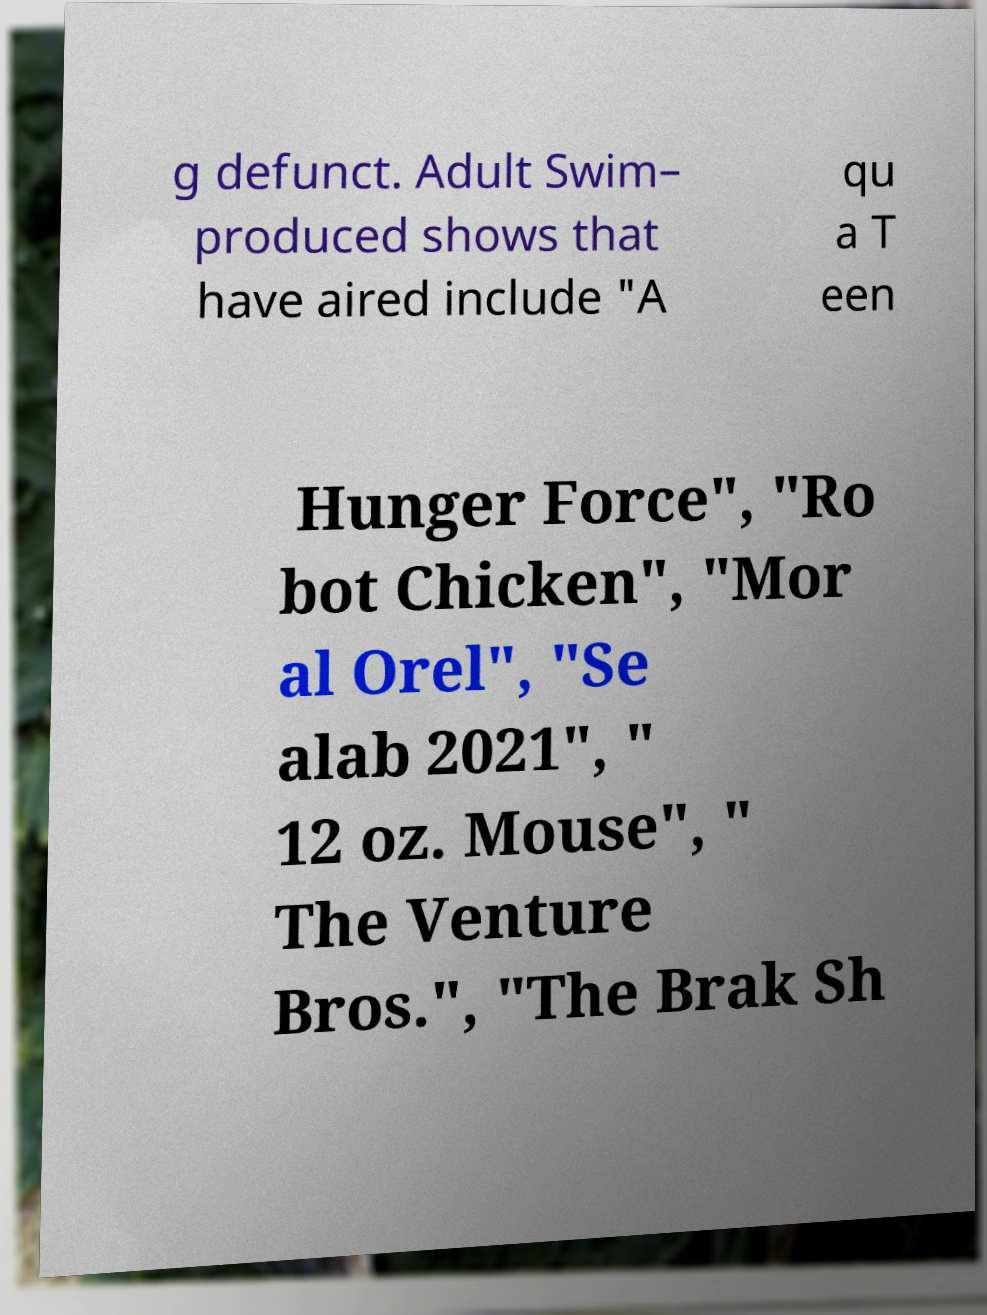Please read and relay the text visible in this image. What does it say? g defunct. Adult Swim– produced shows that have aired include "A qu a T een Hunger Force", "Ro bot Chicken", "Mor al Orel", "Se alab 2021", " 12 oz. Mouse", " The Venture Bros.", "The Brak Sh 